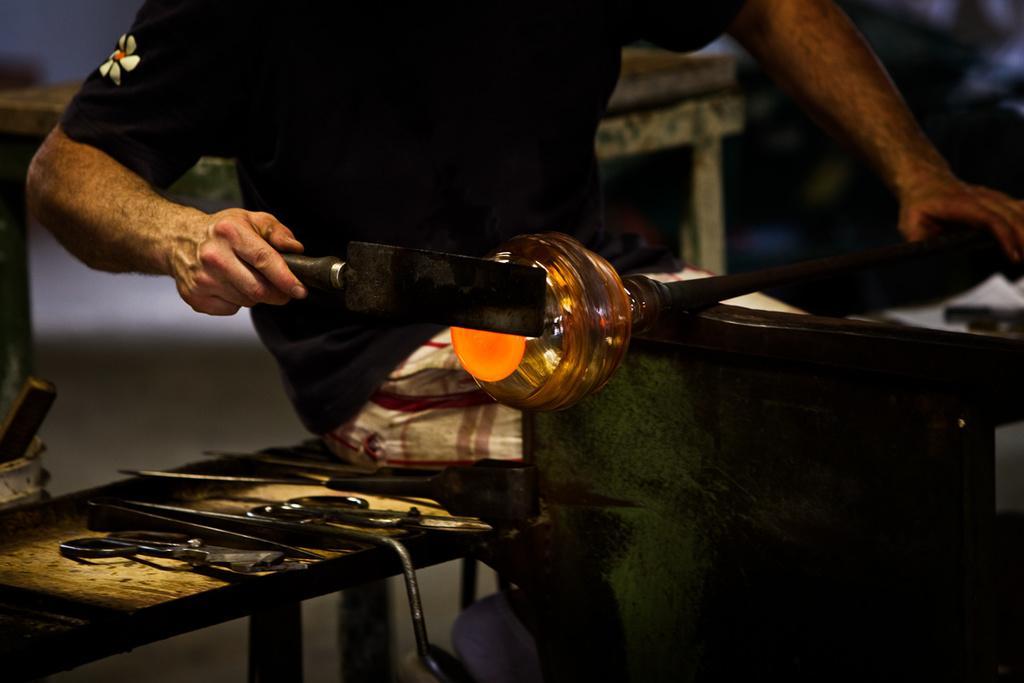Could you give a brief overview of what you see in this image? In this picture we can see a person is sitting on a bench and holding a rod in one hand and in the other hand there is an item and doing some work. On the bench there are some tools and behind the person there are blurred things. 